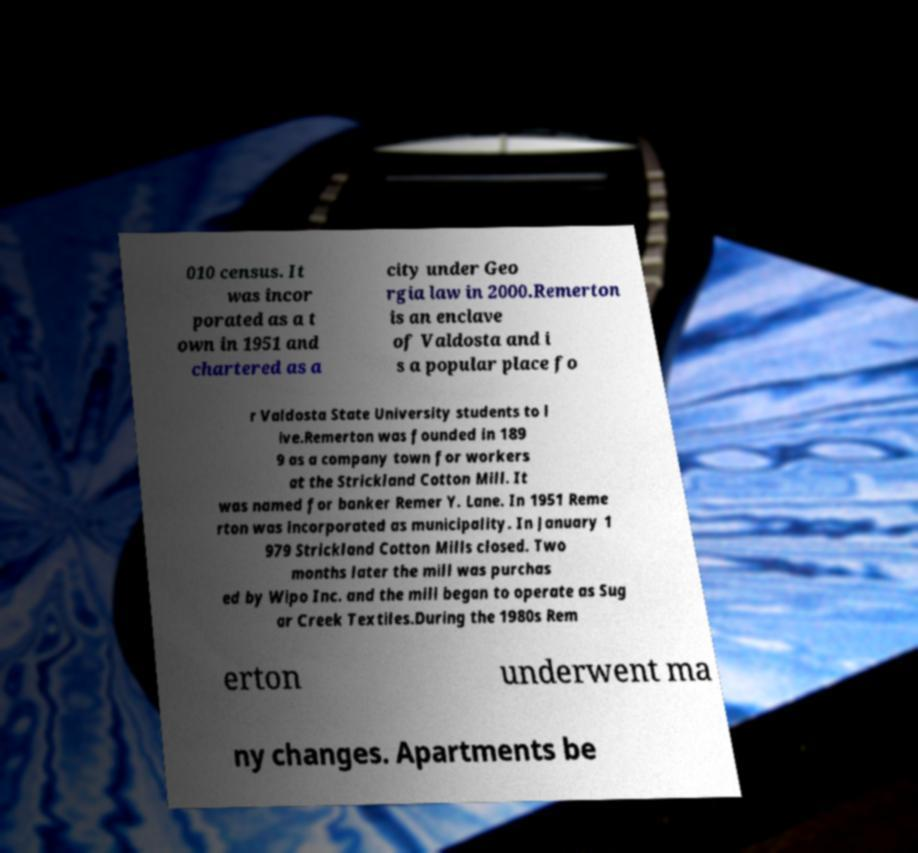I need the written content from this picture converted into text. Can you do that? 010 census. It was incor porated as a t own in 1951 and chartered as a city under Geo rgia law in 2000.Remerton is an enclave of Valdosta and i s a popular place fo r Valdosta State University students to l ive.Remerton was founded in 189 9 as a company town for workers at the Strickland Cotton Mill. It was named for banker Remer Y. Lane. In 1951 Reme rton was incorporated as municipality. In January 1 979 Strickland Cotton Mills closed. Two months later the mill was purchas ed by Wipo Inc. and the mill began to operate as Sug ar Creek Textiles.During the 1980s Rem erton underwent ma ny changes. Apartments be 